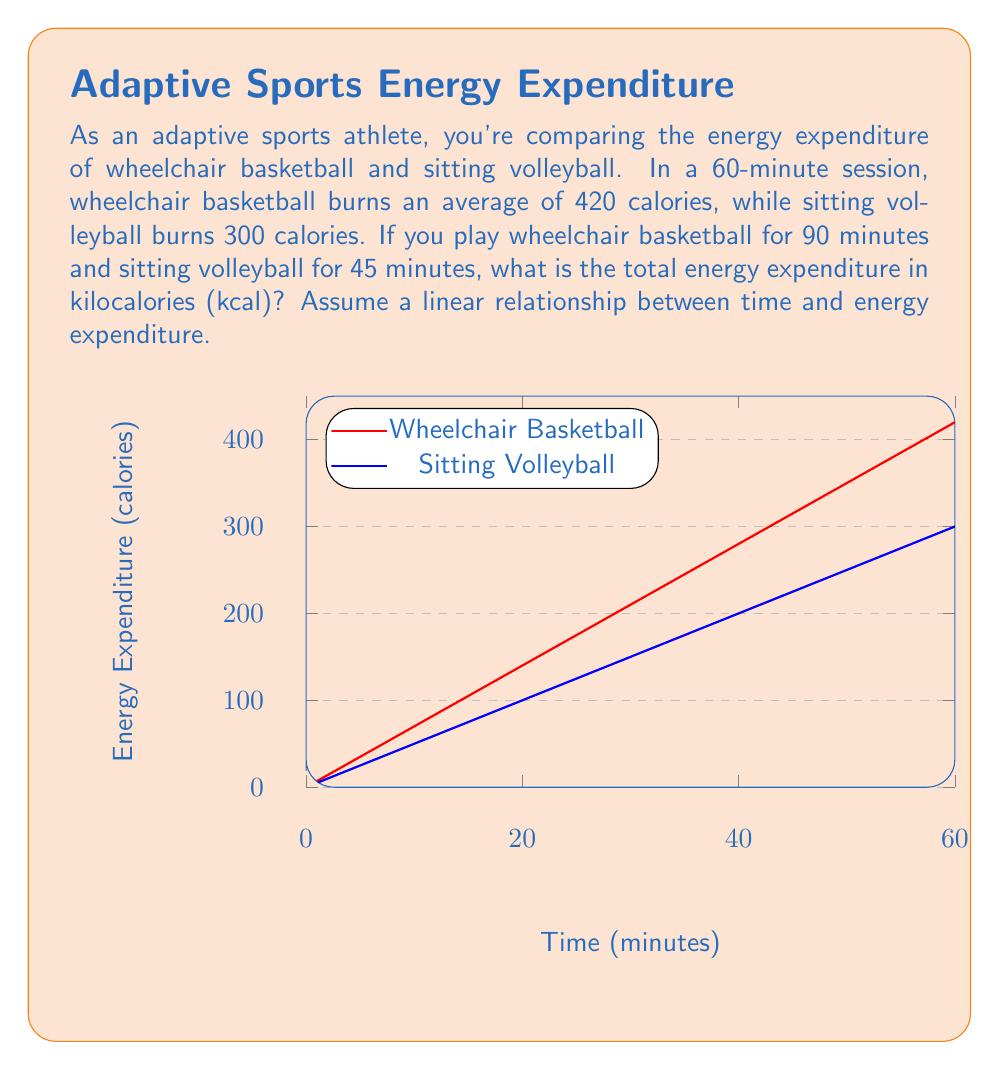Can you solve this math problem? Let's approach this step-by-step:

1) First, we need to calculate the rate of energy expenditure for each sport:

   Wheelchair Basketball: $\frac{420 \text{ calories}}{60 \text{ minutes}} = 7 \text{ calories/minute}$
   Sitting Volleyball: $\frac{300 \text{ calories}}{60 \text{ minutes}} = 5 \text{ calories/minute}$

2) Now, we can calculate the energy expenditure for each activity:

   Wheelchair Basketball (90 minutes): $90 \times 7 = 630 \text{ calories}$
   Sitting Volleyball (45 minutes): $45 \times 5 = 225 \text{ calories}$

3) To get the total energy expenditure, we add these together:

   $630 + 225 = 855 \text{ calories}$

4) The question asks for the answer in kilocalories (kcal). 1 kilocalorie is equal to 1 Calorie (with a capital C), which is the same as 1 food calorie. Therefore, our answer is already in kcal.

   $855 \text{ calories} = 855 \text{ kcal}$
Answer: 855 kcal 